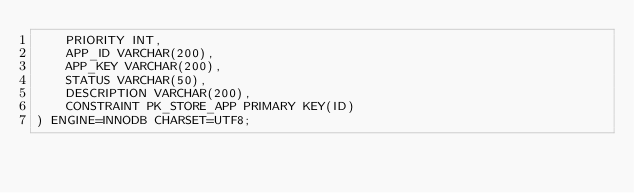<code> <loc_0><loc_0><loc_500><loc_500><_SQL_>	PRIORITY INT,
	APP_ID VARCHAR(200),
	APP_KEY VARCHAR(200),
	STATUS VARCHAR(50),
	DESCRIPTION VARCHAR(200),
    CONSTRAINT PK_STORE_APP PRIMARY KEY(ID)
) ENGINE=INNODB CHARSET=UTF8;
</code> 